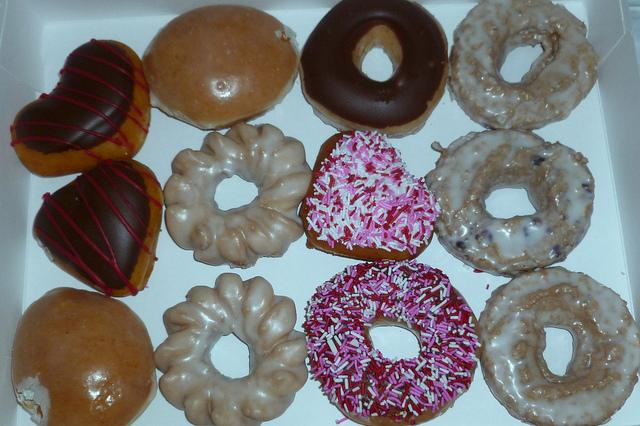How many of the dozen donuts could be cream-filled? five 